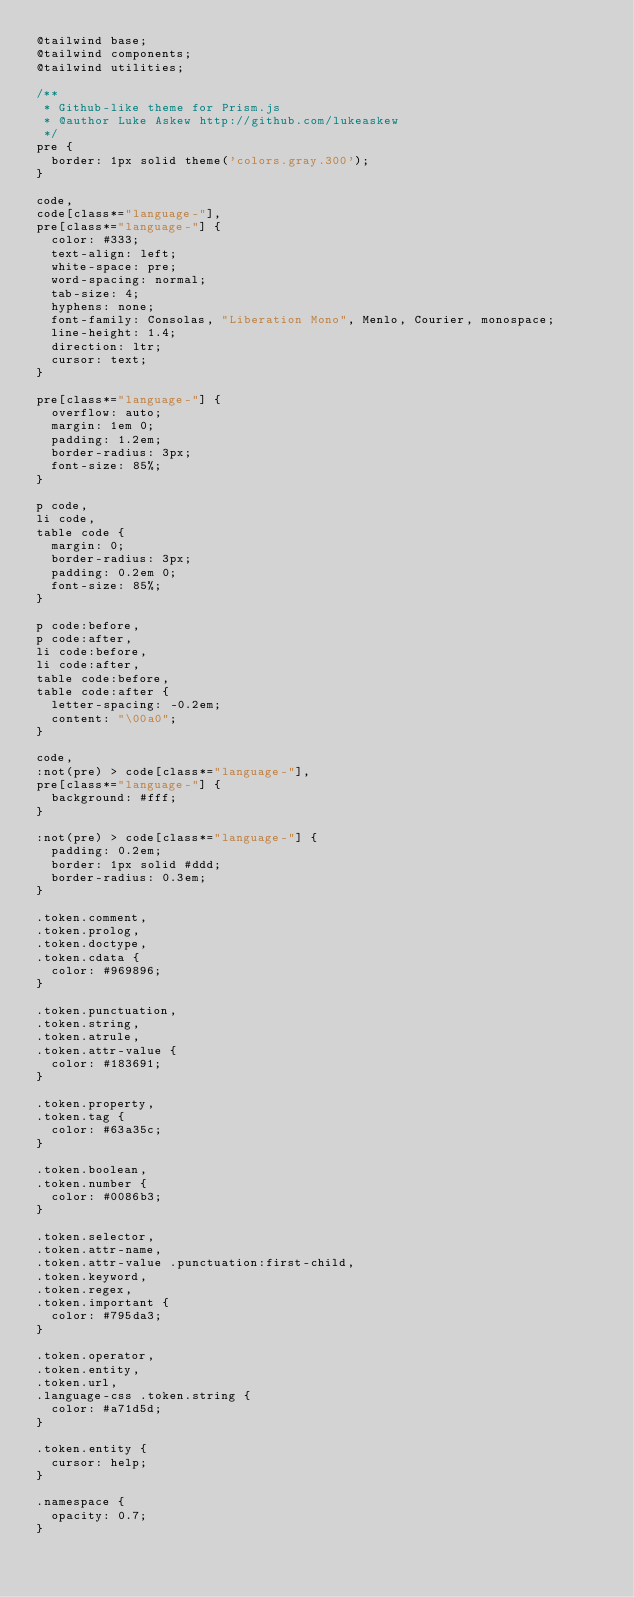Convert code to text. <code><loc_0><loc_0><loc_500><loc_500><_CSS_>@tailwind base;
@tailwind components;
@tailwind utilities;

/**
 * Github-like theme for Prism.js
 * @author Luke Askew http://github.com/lukeaskew
 */
pre {
  border: 1px solid theme('colors.gray.300');
}

code,
code[class*="language-"],
pre[class*="language-"] {
  color: #333;
  text-align: left;
  white-space: pre;
  word-spacing: normal;
  tab-size: 4;
  hyphens: none;
  font-family: Consolas, "Liberation Mono", Menlo, Courier, monospace;
  line-height: 1.4;
  direction: ltr;
  cursor: text;
}

pre[class*="language-"] {
  overflow: auto;
  margin: 1em 0;
  padding: 1.2em;
  border-radius: 3px;
  font-size: 85%;
}

p code,
li code,
table code {
  margin: 0;
  border-radius: 3px;
  padding: 0.2em 0;
  font-size: 85%;
}

p code:before,
p code:after,
li code:before,
li code:after,
table code:before,
table code:after {
  letter-spacing: -0.2em;
  content: "\00a0";
}

code,
:not(pre) > code[class*="language-"],
pre[class*="language-"] {
  background: #fff;
}

:not(pre) > code[class*="language-"] {
  padding: 0.2em;
  border: 1px solid #ddd;
  border-radius: 0.3em;
}

.token.comment,
.token.prolog,
.token.doctype,
.token.cdata {
  color: #969896;
}

.token.punctuation,
.token.string,
.token.atrule,
.token.attr-value {
  color: #183691;
}

.token.property,
.token.tag {
  color: #63a35c;
}

.token.boolean,
.token.number {
  color: #0086b3;
}

.token.selector,
.token.attr-name,
.token.attr-value .punctuation:first-child,
.token.keyword,
.token.regex,
.token.important {
  color: #795da3;
}

.token.operator,
.token.entity,
.token.url,
.language-css .token.string {
  color: #a71d5d;
}

.token.entity {
  cursor: help;
}

.namespace {
  opacity: 0.7;
}
</code> 